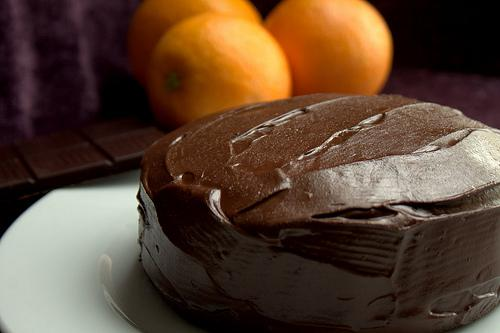Give a brief overview of the main elements depicted in the image. Three oranges and a chocolate cake with smooth frosting are placed on a white plate, with pieces of baking chocolate and a purple fabric in the background. Briefly describe the arrangement of the items in the image. A chocolate cake is placed on a white plate, with three oranges and pieces of baking chocolate to the left, all set against a purple background. Describe the main dessert featured in the image and the accompanying details that add interest to the scene. An uncut chocolate cake with swirled frosting sits on a white plate, accompanied by three oranges, pieces of baking chocolate, and a purple tablecloth. Describe the scene in the image with particular attention to colors and textures. The dark brown, smooth chocolate frosting on the cake contrasts with the bright, shiny oranges, and the white plate against the purple fabric. In one sentence, briefly state the main components of the image. The image features a chocolate cake with frosting on a white plate, three oranges, baking chocolate pieces, and a purple tablecloth. Mention the main focus of the image along with the adjacent items in short. A chocolate cake on a white plate, with three unpeeled oranges and baking chocolate bars beside it, set against a purple background. Explain the composition of the image by highlighting the main subjects and their surroundings. The chocolate cake on a white plate is the center of focus, surrounded by three oranges, bars of baking chocolate, and a purple tablecloth in the background. Write a short sentence capturing the main theme of the image. A chocolate cake and three oranges create an appetizing scene with baking chocolate pieces and a purple backdrop. Write a short sentence describing the primary food items in the picture. A homemade chocolate cake with swirled frosting sits alongside three large oranges on a white plate. Mention how the light highlights the objects in the image. Light reflects on the cake's smooth chocolate frosting and the surface of the oranges, while also creating highlights on the plate and the background fabric. 